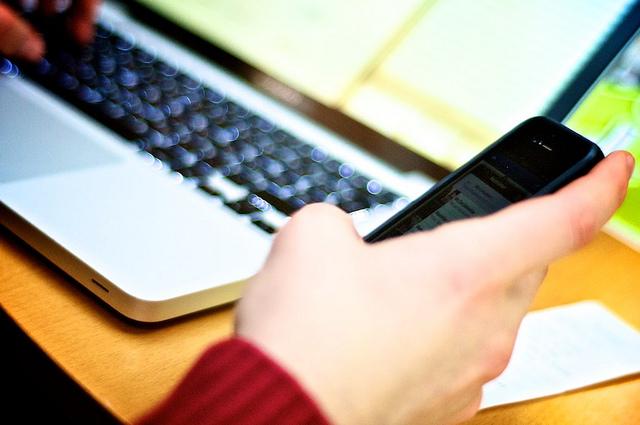What is the person typing on?
Be succinct. Laptop. What is the person holding?
Write a very short answer. Cell phone. What kind of phone is that?
Answer briefly. Nokia. 